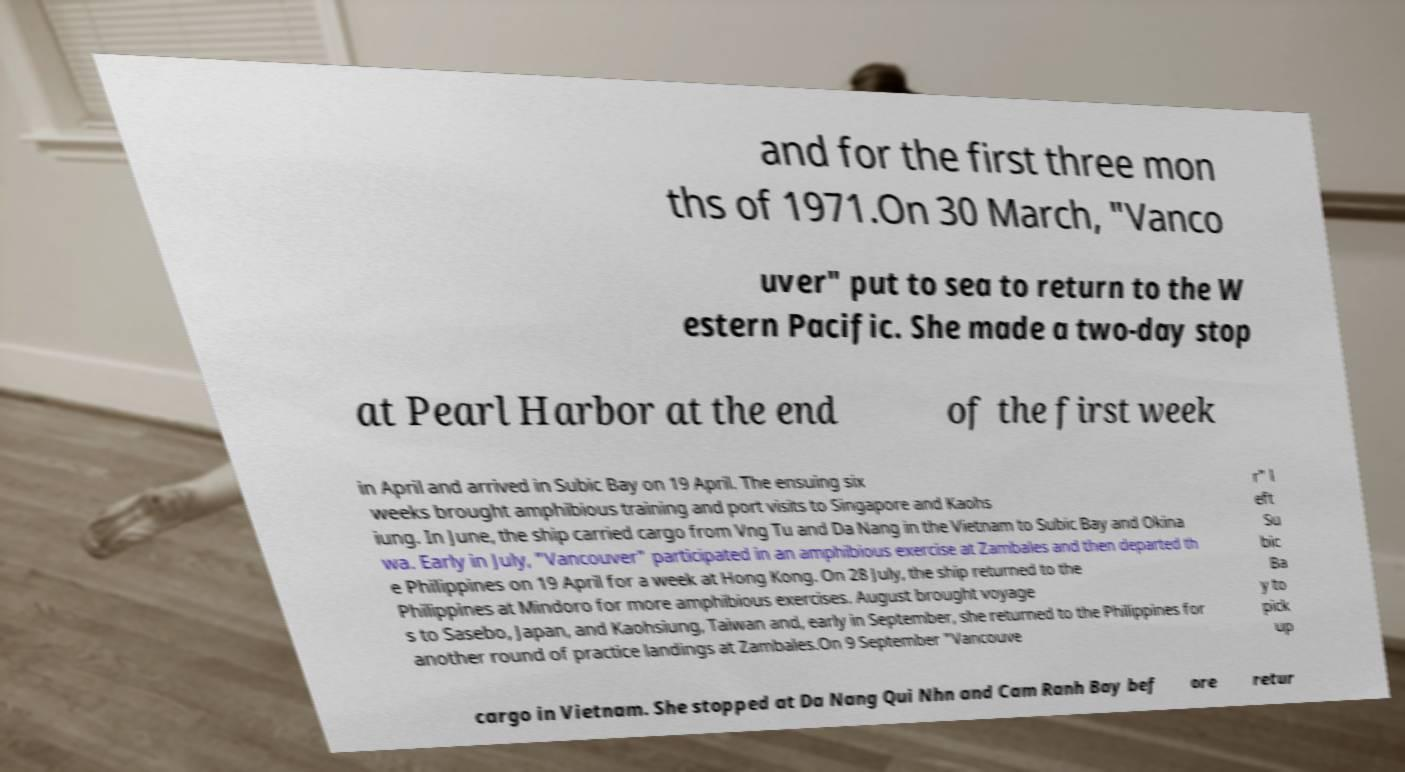For documentation purposes, I need the text within this image transcribed. Could you provide that? and for the first three mon ths of 1971.On 30 March, "Vanco uver" put to sea to return to the W estern Pacific. She made a two-day stop at Pearl Harbor at the end of the first week in April and arrived in Subic Bay on 19 April. The ensuing six weeks brought amphibious training and port visits to Singapore and Kaohs iung. In June, the ship carried cargo from Vng Tu and Da Nang in the Vietnam to Subic Bay and Okina wa. Early in July, "Vancouver" participated in an amphibious exercise at Zambales and then departed th e Philippines on 19 April for a week at Hong Kong. On 28 July, the ship returned to the Philippines at Mindoro for more amphibious exercises. August brought voyage s to Sasebo, Japan, and Kaohsiung, Taiwan and, early in September, she returned to the Philippines for another round of practice landings at Zambales.On 9 September "Vancouve r" l eft Su bic Ba y to pick up cargo in Vietnam. She stopped at Da Nang Qui Nhn and Cam Ranh Bay bef ore retur 